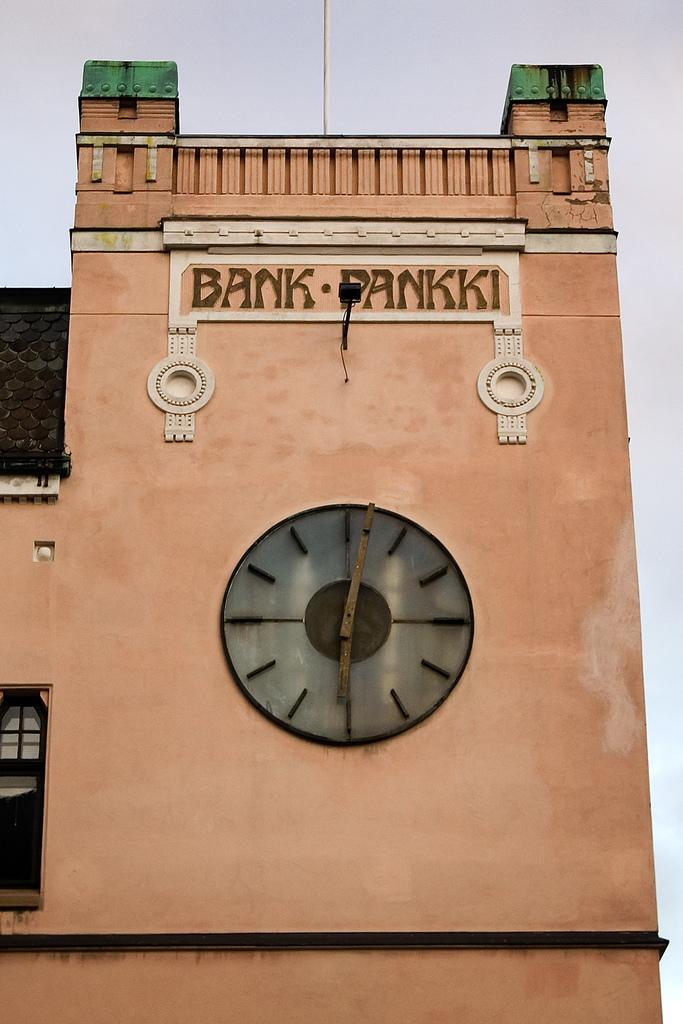<image>
Relay a brief, clear account of the picture shown. A large building that says Bank Pankki and has a clock on its side. 